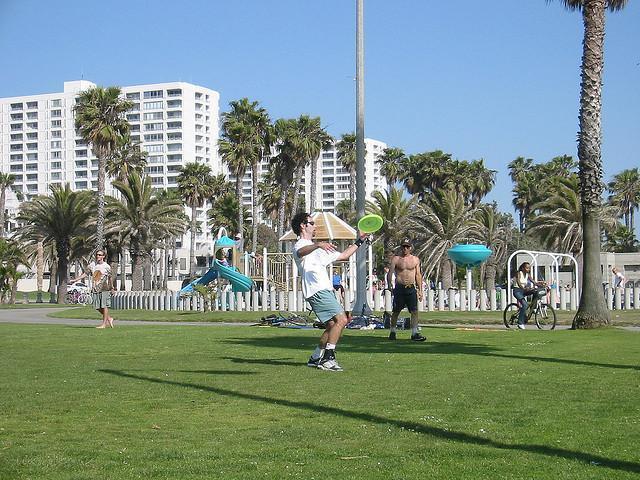How many people are there?
Give a very brief answer. 2. 